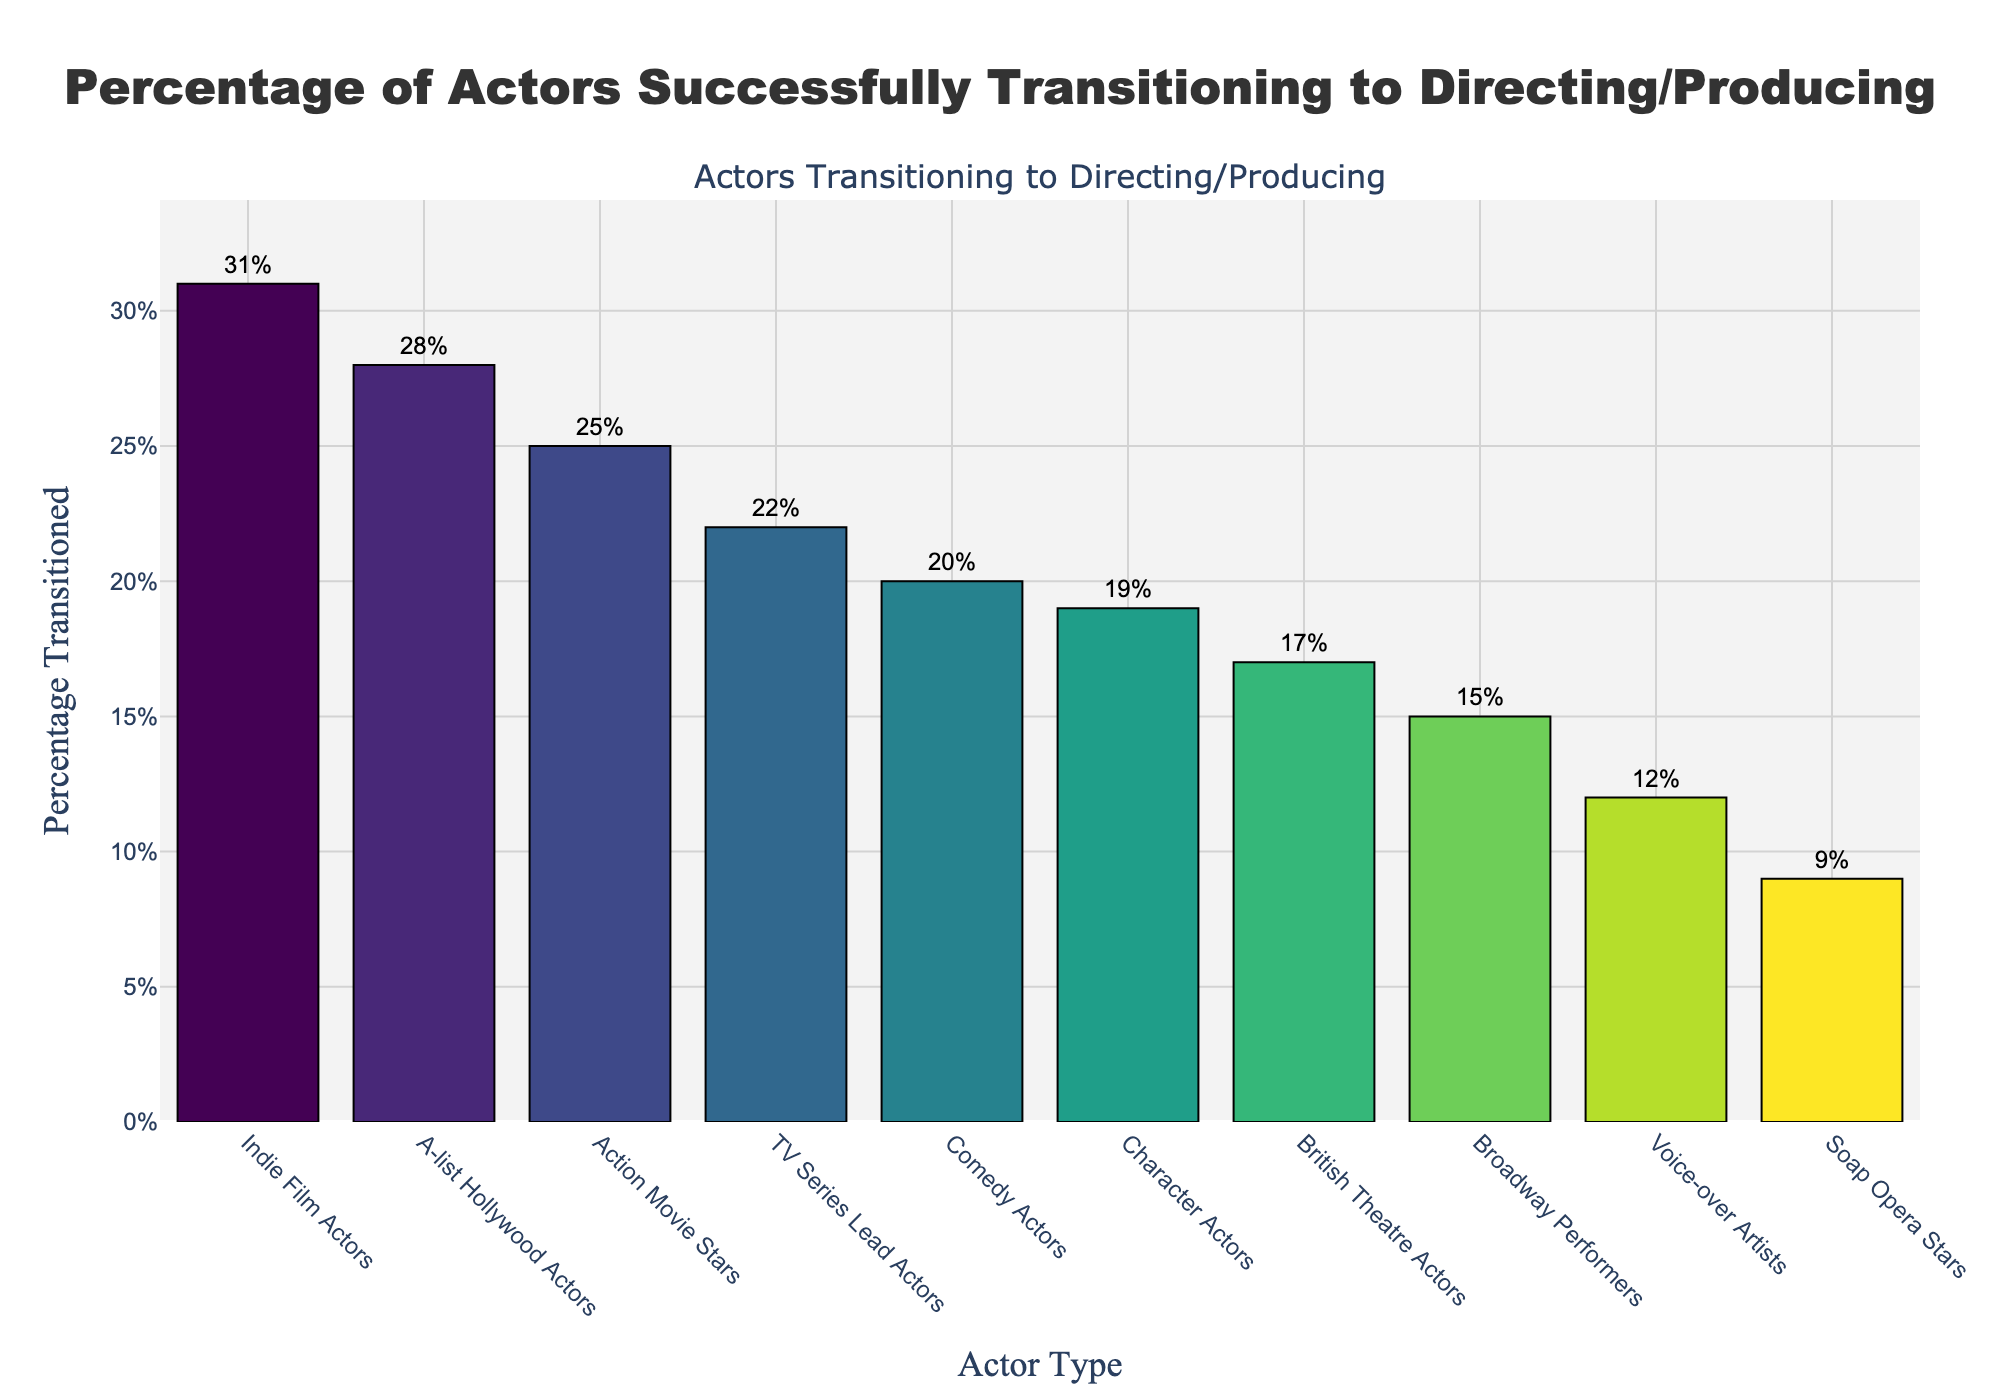Which actor type has the highest percentage of successfully transitioned actors? The figure shows a bar chart where the heights of the bars represent the percentage of actors transitioned. The tallest bar corresponds to Indie Film Actors with a value of 31%
Answer: Indie Film Actors What is the difference in percentage between Soap Opera Stars and Voice-over Artists? From the figure, Soap Opera Stars have 9% and Voice-over Artists have 12%. The difference is calculated as 12% - 9%
Answer: 3% Which actor types have a percentage of successfully transitioned actors of 20% or higher? Looking at the figure, bars that reach or surpass the 20% line are marked as Indie Film Actors (31%), A-list Hollywood Actors (28%), Action Movie Stars (25%), TV Series Lead Actors (22%), and Comedy Actors (20%)
Answer: Indie Film Actors, A-list Hollywood Actors, Action Movie Stars, TV Series Lead Actors, Comedy Actors What is the average percentage of successfully transitioned actors for Broadway Performers, British Theatre Actors, and Character Actors? The percentages for Broadway Performers, British Theatre Actors, and Character Actors are 15%, 17%, and 19%, respectively. The average is calculated as (15 + 17 + 19) / 3 = 17%
Answer: 17% How many actor types have successfully transitioned actor percentages below 15%? By observing the bars that fall below the 15% mark, the actor types are Soap Opera Stars (9%) and Voice-over Artists (12%). Thus, there are two actor types
Answer: 2 Which actor type has a slightly lower percentage of successfully transitioned actors, Broadway Performers or British Theatre Actors? From the figure, Broadway Performers have 15% and British Theatre Actors have 17%. Broadway Performers have a slightly lower percentage
Answer: Broadway Performers Are there more actor types with less than 20% or with 20% and above successfully transitioned actors? Counting the bars, there are five actor types with less than 20% and five with 20% or above. Therefore, the numbers are equal
Answer: Equal Compare the percentage difference between A-list Hollywood Actors and Comedy Actors. A-list Hollywood Actors have 28% and Comedy Actors have 20%. The difference is calculated as 28% - 20%
Answer: 8% What's the sum of the percentages of TV Series Lead Actors, Character Actors, and Indie Film Actors? The percentages for TV Series Lead Actors, Character Actors, and Indie Film Actors are 22%, 19%, and 31%, respectively. The sum is calculated as 22 + 19 + 31 = 72%
Answer: 72% Which actor type has a lower transition percentage than Comedy Actors but higher than British Theatre Actors? By looking at the figure, Comedy Actors are at 20%, and British Theatre Actors are at 17%. The actor type that fits the criteria is Character Actors at 19%
Answer: Character Actors 